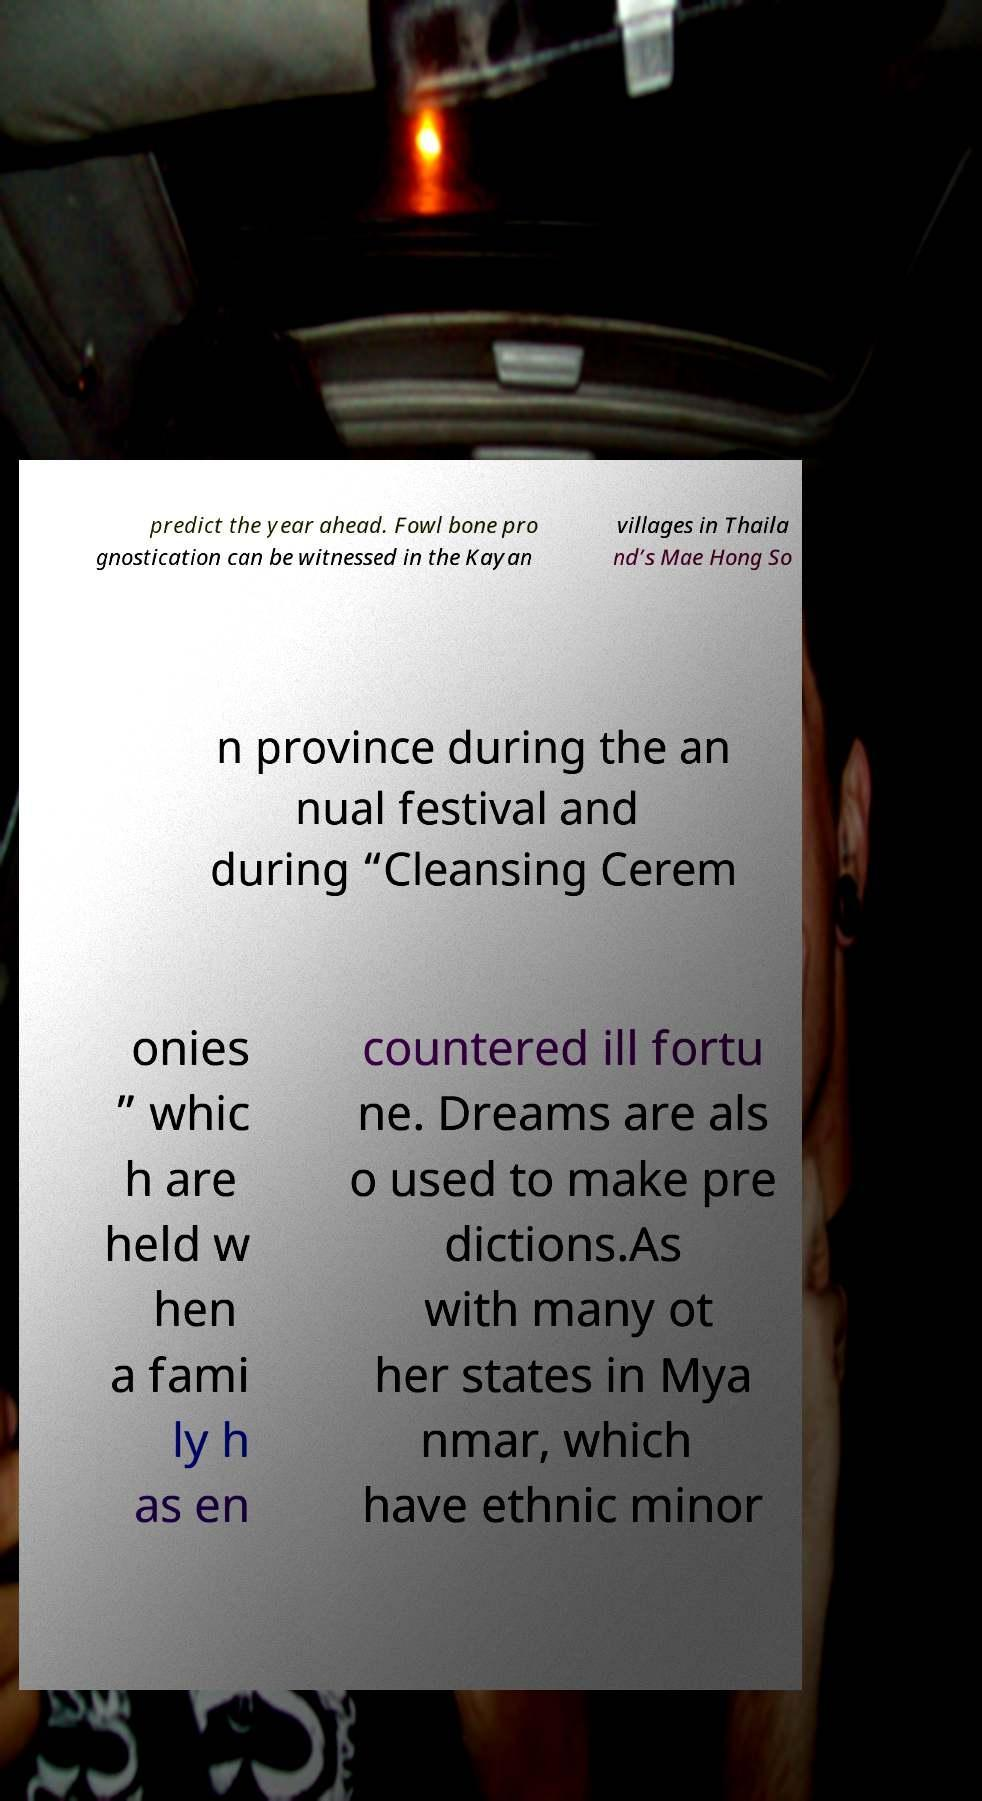Please read and relay the text visible in this image. What does it say? predict the year ahead. Fowl bone pro gnostication can be witnessed in the Kayan villages in Thaila nd’s Mae Hong So n province during the an nual festival and during “Cleansing Cerem onies ” whic h are held w hen a fami ly h as en countered ill fortu ne. Dreams are als o used to make pre dictions.As with many ot her states in Mya nmar, which have ethnic minor 